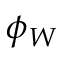Convert formula to latex. <formula><loc_0><loc_0><loc_500><loc_500>\phi _ { W }</formula> 